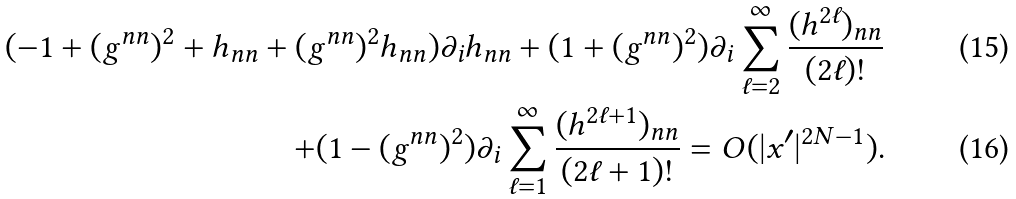Convert formula to latex. <formula><loc_0><loc_0><loc_500><loc_500>( - 1 + ( g ^ { n n } ) ^ { 2 } + h _ { n n } + ( g ^ { n n } ) ^ { 2 } h _ { n n } ) \partial _ { i } h _ { n n } + ( 1 + ( g ^ { n n } ) ^ { 2 } ) \partial _ { i } \sum _ { \ell = 2 } ^ { \infty } \frac { ( h ^ { 2 \ell } ) _ { n n } } { ( 2 \ell ) ! } \\ + ( 1 - ( g ^ { n n } ) ^ { 2 } ) \partial _ { i } \sum _ { \ell = 1 } ^ { \infty } \frac { ( h ^ { 2 \ell + 1 } ) _ { n n } } { ( 2 \ell + 1 ) ! } = O ( | x ^ { \prime } | ^ { 2 N - 1 } ) .</formula> 